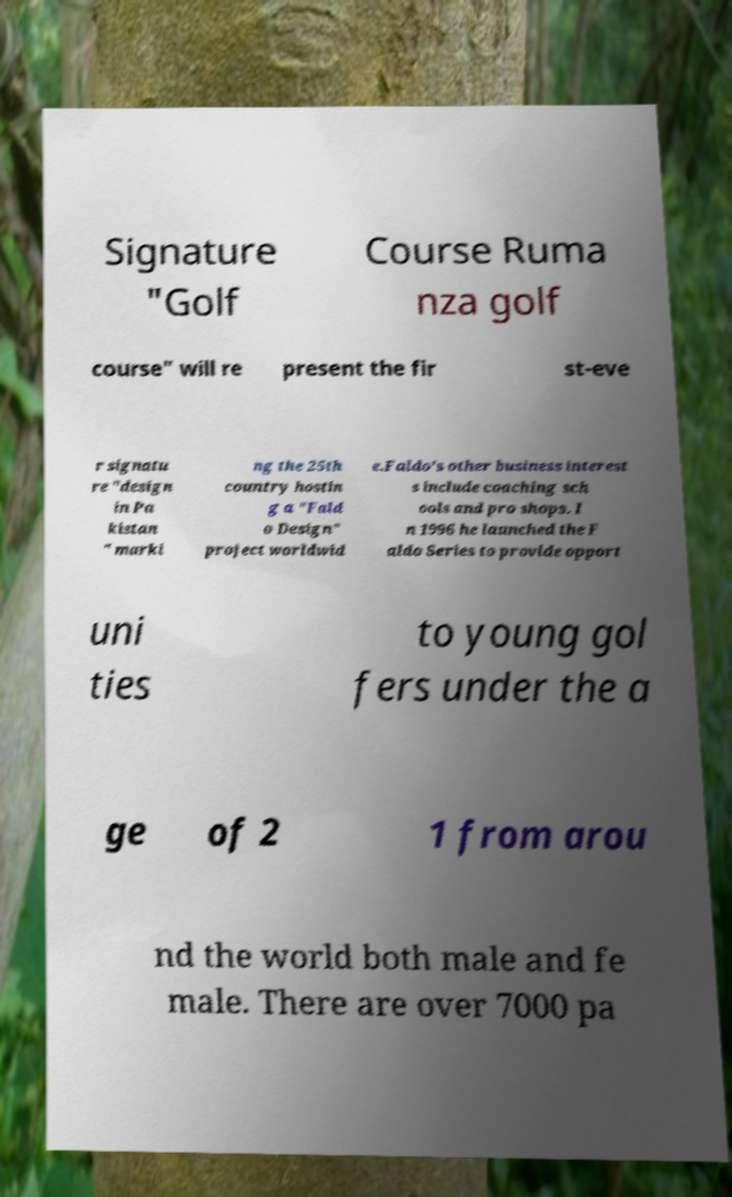I need the written content from this picture converted into text. Can you do that? Signature "Golf Course Ruma nza golf course" will re present the fir st-eve r signatu re "design in Pa kistan " marki ng the 25th country hostin g a "Fald o Design" project worldwid e.Faldo's other business interest s include coaching sch ools and pro shops. I n 1996 he launched the F aldo Series to provide opport uni ties to young gol fers under the a ge of 2 1 from arou nd the world both male and fe male. There are over 7000 pa 